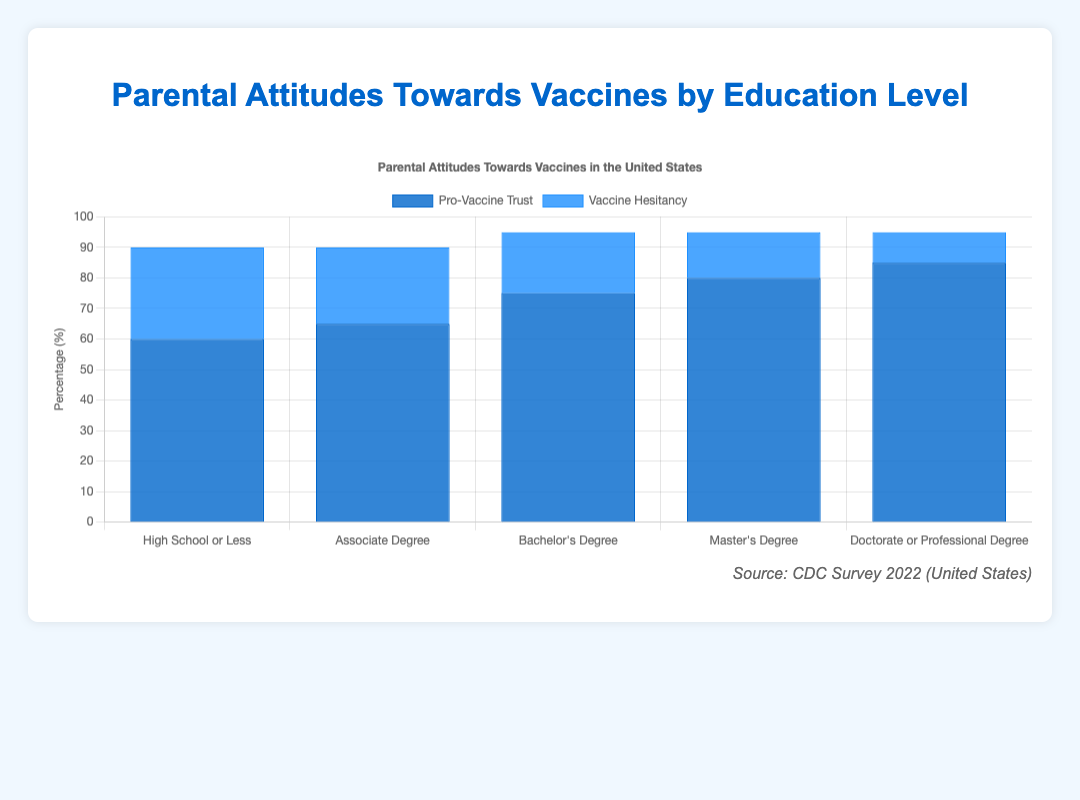What is the highest percentage of "Pro-Vaccine Trust" and which education level does it correspond to? The highest percentage of "Pro-Vaccine Trust" can be determined by looking at the tallest blue bar in the chart. The tallest bar corresponds to the "Doctorate or Professional Degree" education level, and its height indicates a value of 85%.
Answer: 85%, Doctorate or Professional Degree How much higher is the "Pro-Vaccine Trust" percentage for "Bachelor's Degree" compared to "High School or Less"? To find the difference, subtract the "Pro-Vaccine Trust" percentage for "High School or Less" (60%) from that of "Bachelor's Degree" (75%). The difference is 75% - 60% = 15%.
Answer: 15% What's the average "Vaccine Hesitancy" across all education levels shown in the chart? To find the average, add up the "Vaccine Hesitancy" percentages for all education levels (30 + 25 + 20 + 15 + 10 = 100), then divide by the number of education levels (5). The average is 100/5 = 20%.
Answer: 20% Which education level has an equal percentage of "Pro-Vaccine Trust" and "Anti-Vaccine Sentiment"? The chart shows that "Doctorate or Professional Degree" has 85% "Pro-Vaccine Trust" and a different value for "Anti-Vaccine Sentiment". Therefore, no education level has equal percentages for these two categories.
Answer: None Is the "Pro-Vaccine Trust" percentage for "High School or Less" greater than the "Vaccine Hesitancy" percentage for "Master's Degree"? Compare the "Pro-Vaccine Trust" percentage for "High School or Less" (60%) with the "Vaccine Hesitancy" percentage for "Master's Degree" (15%). Since 60% is greater than 15%, the statement is true.
Answer: Yes What is the sum of the "Pro-Vaccine Trust" percentages for "Associate Degree" and "Bachelor's Degree"? Add the "Pro-Vaccine Trust" percentages for "Associate Degree" (65%) and "Bachelor's Degree" (75%). The sum is 65% + 75% = 140%.
Answer: 140% Which education level has the lowest "Vaccine Hesitancy" percentage and what is the value? The lowest "Vaccine Hesitancy" percentage corresponds to the shortest dark blue bar in the chart. The shortest bar is for "Doctorate or Professional Degree" with a value of 10%.
Answer: Doctorate or Professional Degree, 10% What is the range of "Vaccine Hesitancy" percentages across all education levels? The range is the difference between the highest and lowest "Vaccine Hesitancy" percentages. The highest is 30% (High School or Less) and the lowest is 10% (Doctorate or Professional Degree). The range is 30% - 10% = 20%.
Answer: 20% How do the "Pro-Vaccine Trust" percentages for "Associate Degree" and "Master's Degree" compare? The "Pro-Vaccine Trust" percentage for "Associate Degree" is 65%, while for "Master's Degree" it is 80%. Since 80% is greater than 65%, the "Pro-Vaccine Trust" percentage is higher for "Master's Degree".
Answer: Master's Degree is higher Are there more education levels with "Pro-Vaccine Trust" percentages higher than 70% or with "Vaccine Hesitancy" percentages higher than 20%? "Pro-Vaccine Trust" percentages higher than 70% include "Bachelor's Degree", "Master's Degree", and "Doctorate or Professional Degree" (3 levels). "Vaccine Hesitancy" percentages higher than 20% include "High School or Less" and "Associate Degree" (2 levels). There are more education levels with "Pro-Vaccine Trust" percentages higher than 70%.
Answer: More with "Pro-Vaccine Trust" higher than 70% 